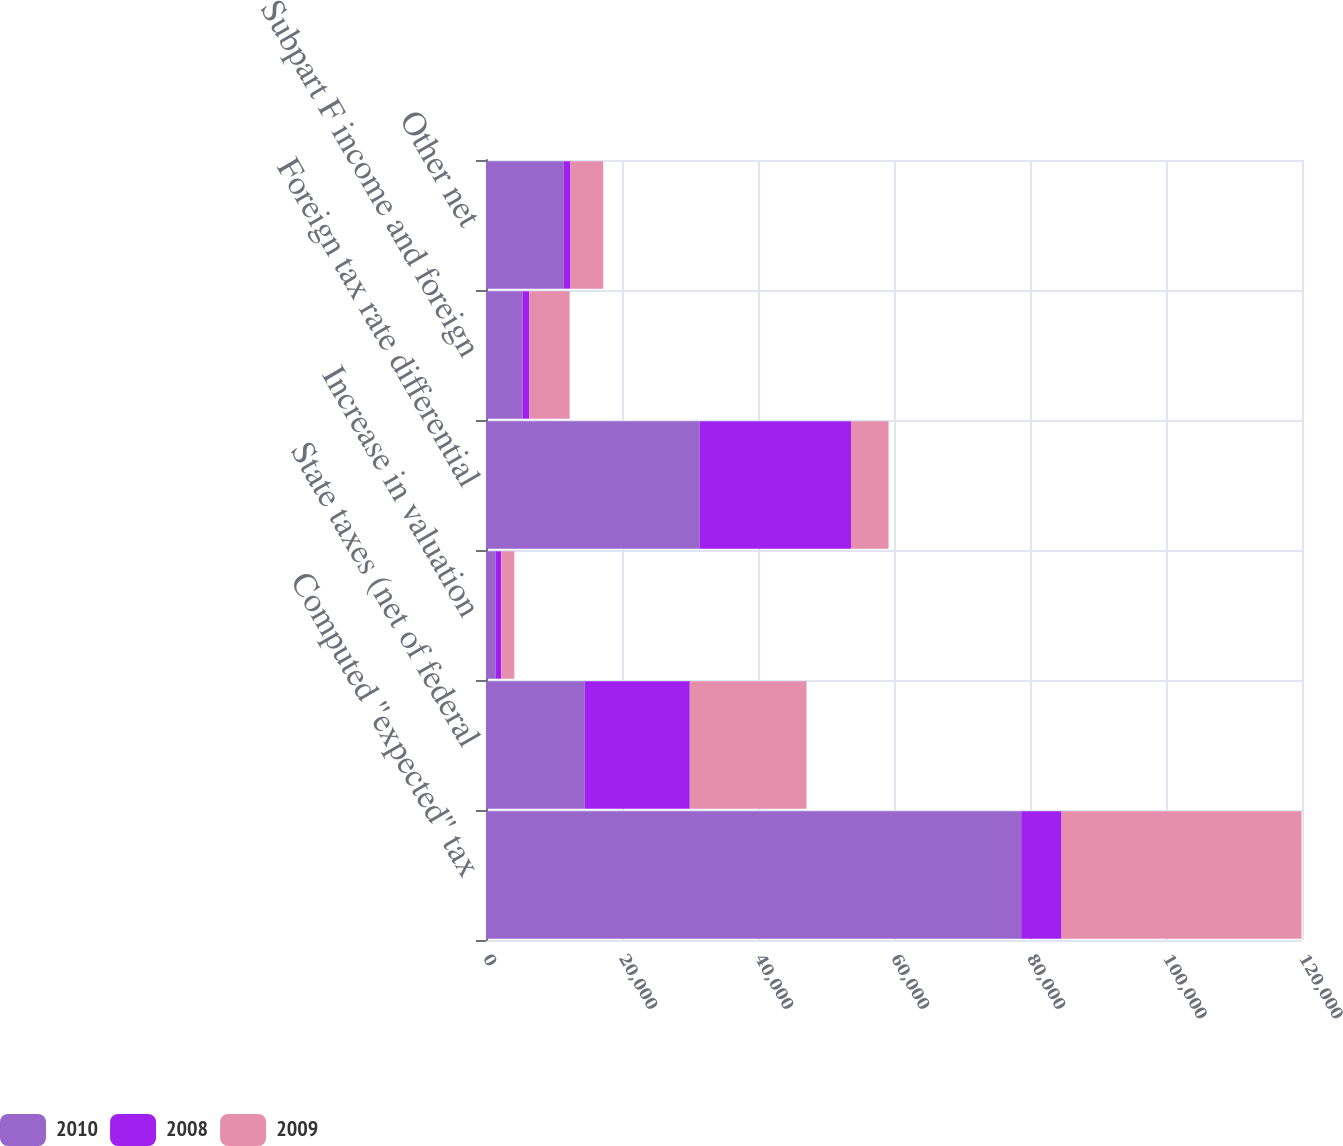Convert chart to OTSL. <chart><loc_0><loc_0><loc_500><loc_500><stacked_bar_chart><ecel><fcel>Computed ''expected'' tax<fcel>State taxes (net of federal<fcel>Increase in valuation<fcel>Foreign tax rate differential<fcel>Subpart F income and foreign<fcel>Other net<nl><fcel>2010<fcel>78703<fcel>14520<fcel>1439<fcel>31443<fcel>5368<fcel>11451<nl><fcel>2008<fcel>5943<fcel>15451<fcel>808<fcel>22232<fcel>984<fcel>976<nl><fcel>2009<fcel>35278<fcel>17163<fcel>1920<fcel>5524<fcel>5943<fcel>4812<nl></chart> 